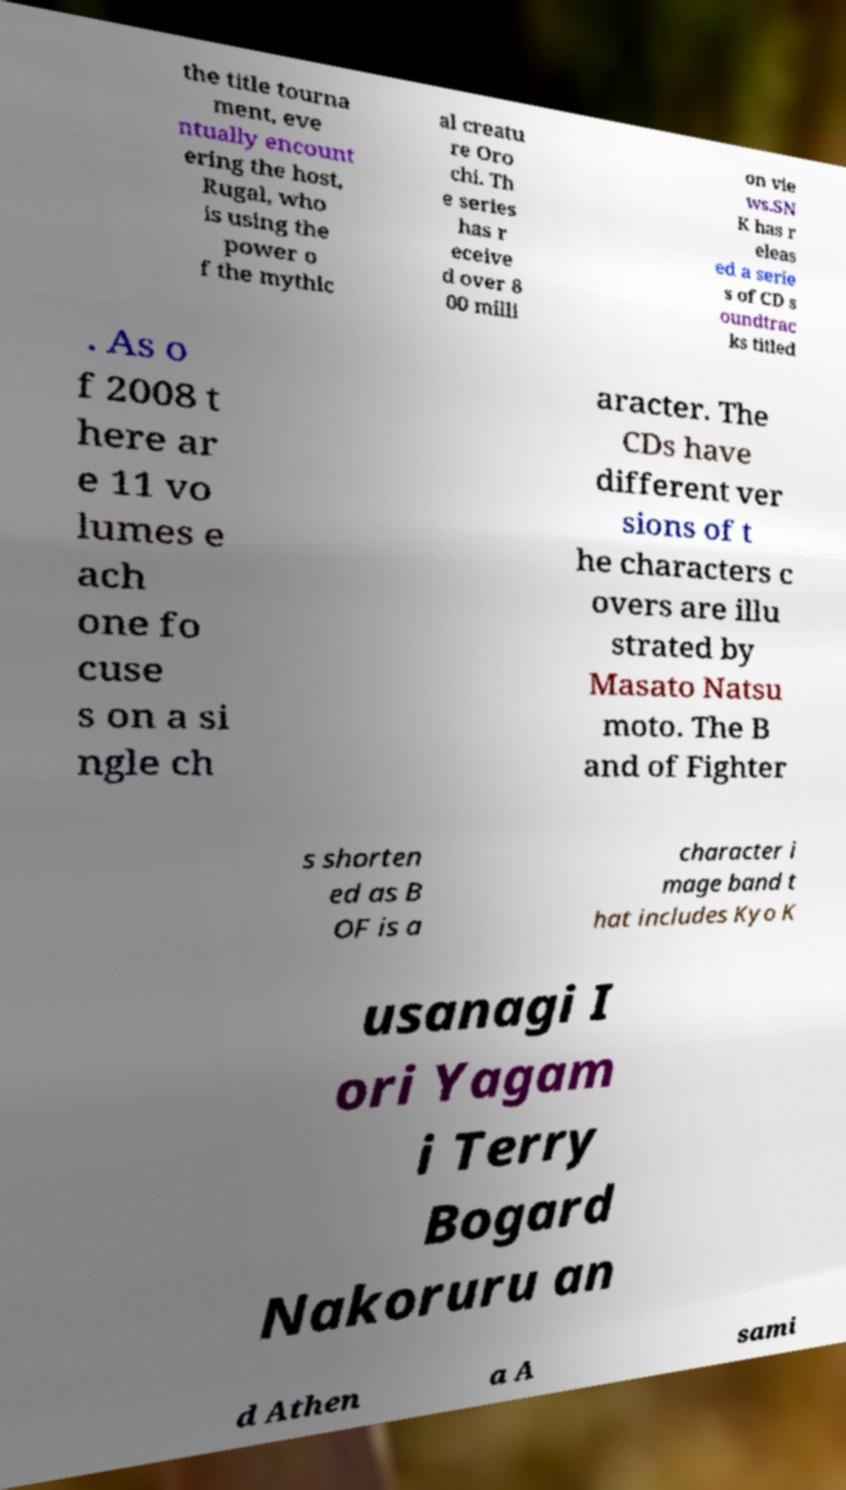For documentation purposes, I need the text within this image transcribed. Could you provide that? the title tourna ment, eve ntually encount ering the host, Rugal, who is using the power o f the mythic al creatu re Oro chi. Th e series has r eceive d over 8 00 milli on vie ws.SN K has r eleas ed a serie s of CD s oundtrac ks titled . As o f 2008 t here ar e 11 vo lumes e ach one fo cuse s on a si ngle ch aracter. The CDs have different ver sions of t he characters c overs are illu strated by Masato Natsu moto. The B and of Fighter s shorten ed as B OF is a character i mage band t hat includes Kyo K usanagi I ori Yagam i Terry Bogard Nakoruru an d Athen a A sami 